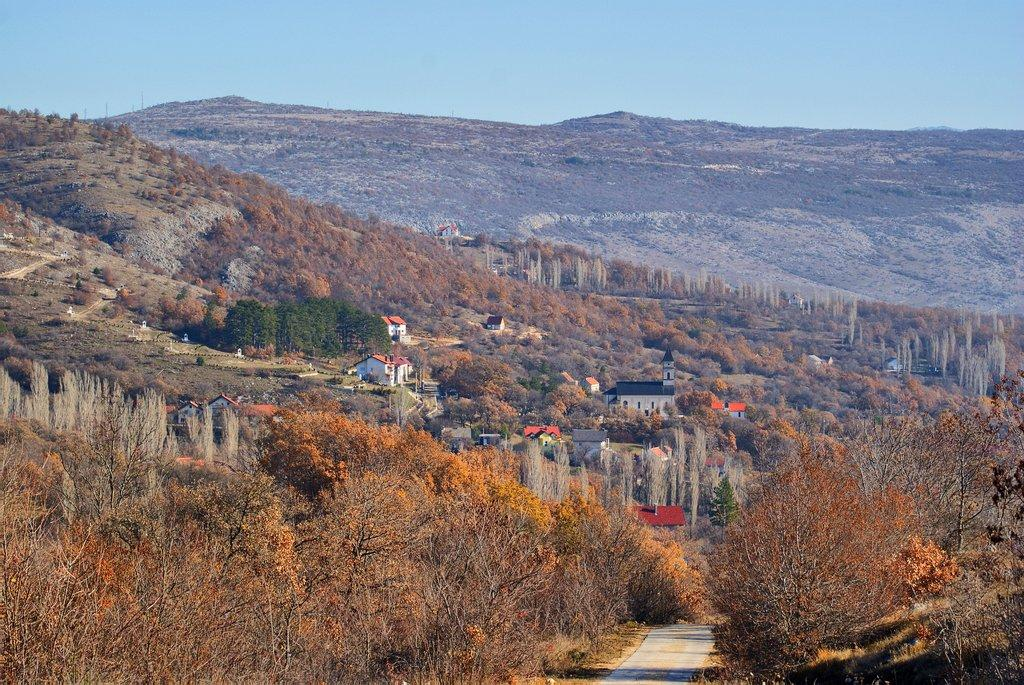What type of vegetation is present at the bottom of the image? There are trees at the bottom of the image. What type of structures are also present at the bottom of the image? There are houses at the bottom of the image. What natural feature can be seen in the background of the image? There are mountains in the background of the image. What is visible part of the environment is at the top of the image? The sky is visible at the top of the image. What type of business is being conducted in the image? There is no indication of any business activity in the image. Is there any motion or movement happening in the image? The image appears to be a still photograph, so there is no visible motion or movement. 